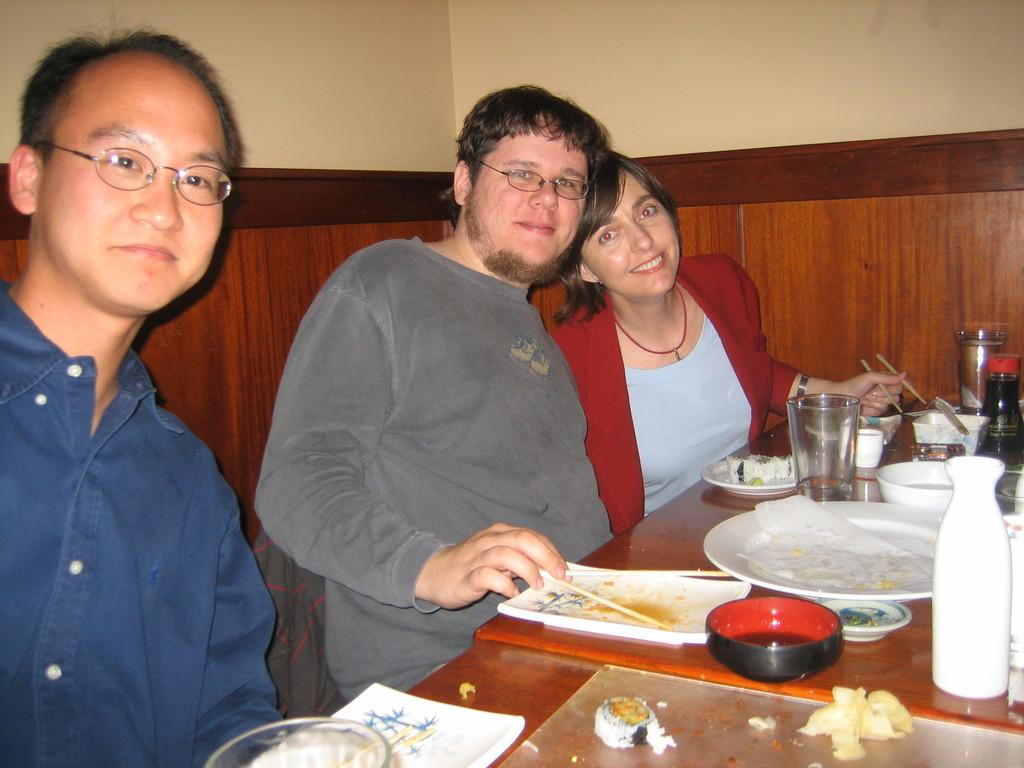How many people are sitting on the sofa in the image? There are three persons sitting on the sofa in the image. What is present on the table in the image? There are bowls, bottles, and plates on the table in the image. What can be seen in the background of the image? A: There is a wall in the background of the image. What day of the week is it in the image? The day of the week is not mentioned or visible in the image, so it cannot be determined. How do the persons sitting on the sofa show care for each other in the image? The image does not provide information about how the persons are interacting or showing care for each other, so it cannot be determined. 